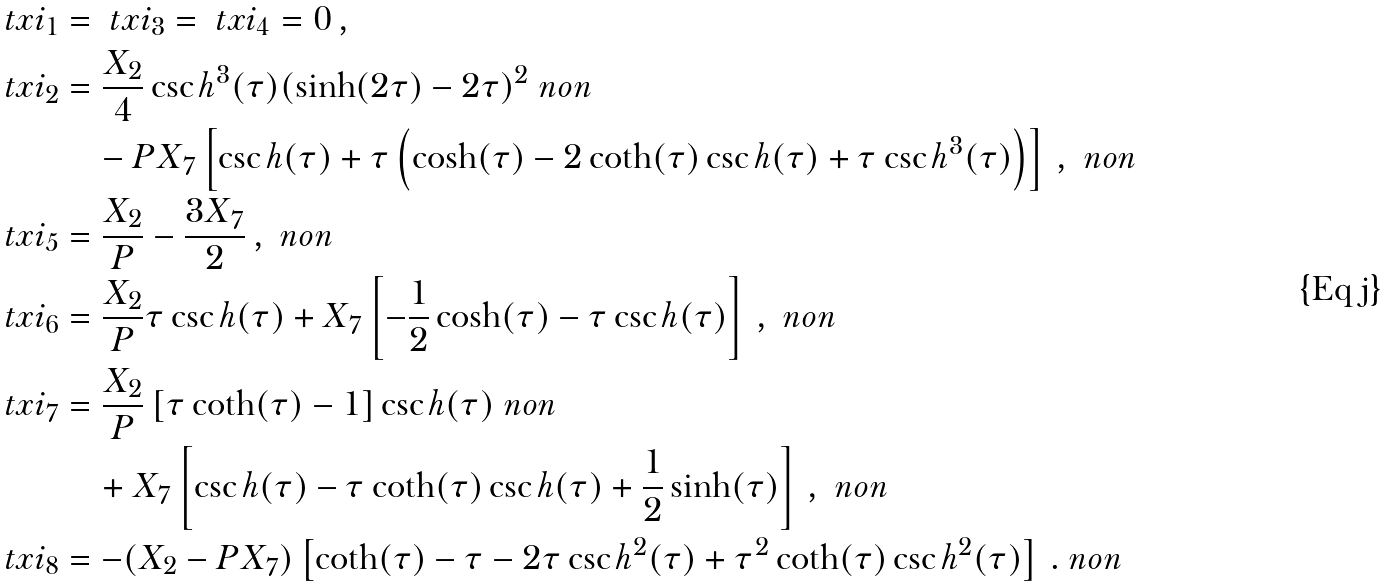Convert formula to latex. <formula><loc_0><loc_0><loc_500><loc_500>\ t x i _ { 1 } & = \ t x i _ { 3 } = \ t x i _ { 4 } = 0 \, , \\ \ t x i _ { 2 } & = \frac { X _ { 2 } } { 4 } \csc h ^ { 3 } ( \tau ) ( \sinh ( 2 \tau ) - 2 \tau ) ^ { 2 } \ n o n \\ & \quad - P X _ { 7 } \left [ \csc h ( \tau ) + \tau \left ( \cosh ( \tau ) - 2 \coth ( \tau ) \csc h ( \tau ) + \tau \csc h ^ { 3 } ( \tau ) \right ) \right ] \, , \ n o n \\ \ t x i _ { 5 } & = \frac { X _ { 2 } } { P } - \frac { 3 X _ { 7 } } { 2 } \, , \ n o n \\ \ t x i _ { 6 } & = \frac { X _ { 2 } } { P } \tau \csc h ( \tau ) + X _ { 7 } \left [ - \frac { 1 } { 2 } \cosh ( \tau ) - \tau \csc h ( \tau ) \right ] \, , \ n o n \\ \ t x i _ { 7 } & = \frac { X _ { 2 } } { P } \left [ \tau \coth ( \tau ) - 1 \right ] \csc h ( \tau ) \ n o n \\ & \quad + X _ { 7 } \left [ \csc h ( \tau ) - \tau \coth ( \tau ) \csc h ( \tau ) + \frac { 1 } { 2 } \sinh ( \tau ) \right ] \, , \ n o n \\ \ t x i _ { 8 } & = - ( X _ { 2 } - P X _ { 7 } ) \left [ \coth ( \tau ) - \tau - 2 \tau \csc h ^ { 2 } ( \tau ) + \tau ^ { 2 } \coth ( \tau ) \csc h ^ { 2 } ( \tau ) \right ] \, . \ n o n</formula> 